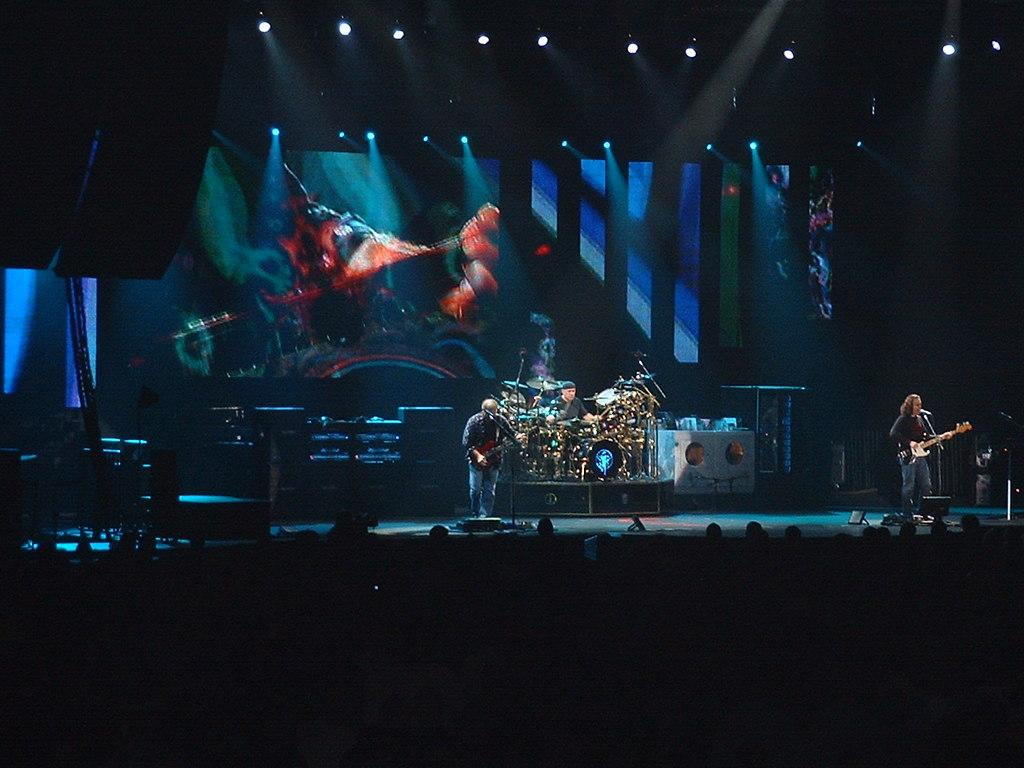What are the people in the image doing? People are playing musical instruments in the image. What can be seen beneath the people in the image? There is a floor visible in the image. What can be seen illuminating the scene in the image? Lights are present in the image. What is the large, flat object in the image? There is a screen in the image. What other objects can be seen in the image besides the musical instruments and screen? Other objects are visible in the image. How would you describe the lighting at the bottom of the image? The bottom of the image is dark. What type of education is being taught on the screen in the image? There is no screen visible in the image that displays educational content. Can you see the approval rating of the band on the screen in the image? There is no screen visible in the image that displays approval ratings. 